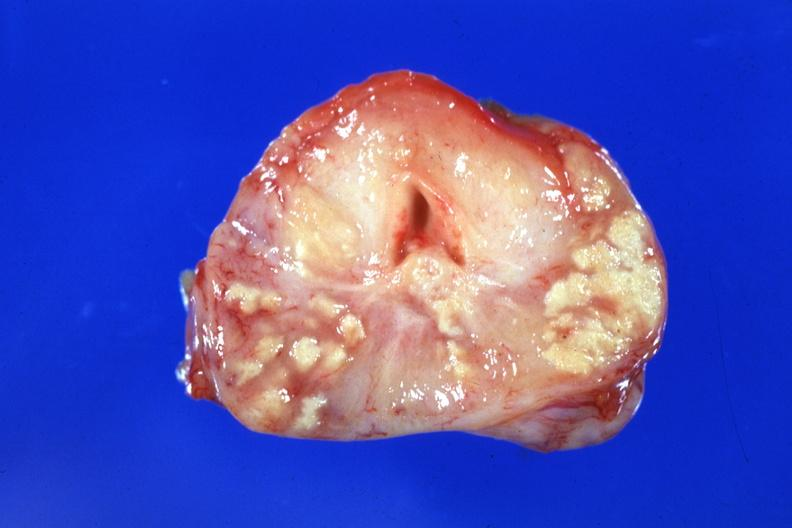s prostate present?
Answer the question using a single word or phrase. Yes 